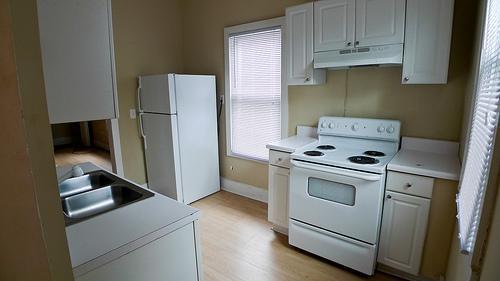How many windows are shown?
Give a very brief answer. 2. How many knobs are on the oven?
Give a very brief answer. 5. How many burners are on the stove top?
Give a very brief answer. 4. How many fronts of cabinet doors are visible?
Give a very brief answer. 6. How many doorways are shown?
Give a very brief answer. 1. 